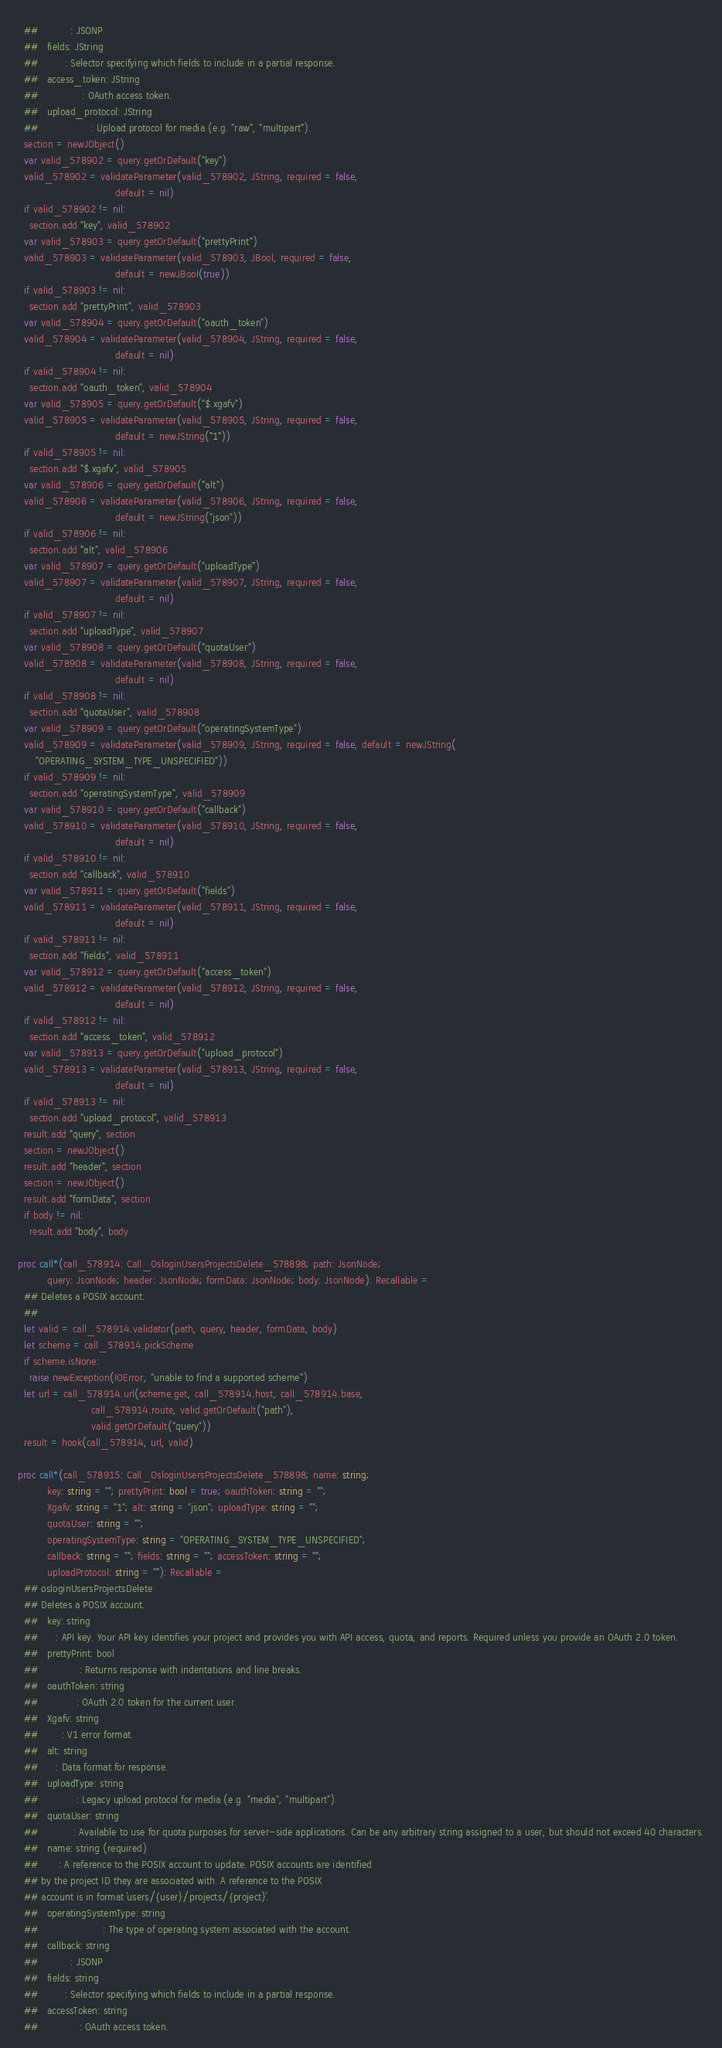<code> <loc_0><loc_0><loc_500><loc_500><_Nim_>  ##           : JSONP
  ##   fields: JString
  ##         : Selector specifying which fields to include in a partial response.
  ##   access_token: JString
  ##               : OAuth access token.
  ##   upload_protocol: JString
  ##                  : Upload protocol for media (e.g. "raw", "multipart").
  section = newJObject()
  var valid_578902 = query.getOrDefault("key")
  valid_578902 = validateParameter(valid_578902, JString, required = false,
                                 default = nil)
  if valid_578902 != nil:
    section.add "key", valid_578902
  var valid_578903 = query.getOrDefault("prettyPrint")
  valid_578903 = validateParameter(valid_578903, JBool, required = false,
                                 default = newJBool(true))
  if valid_578903 != nil:
    section.add "prettyPrint", valid_578903
  var valid_578904 = query.getOrDefault("oauth_token")
  valid_578904 = validateParameter(valid_578904, JString, required = false,
                                 default = nil)
  if valid_578904 != nil:
    section.add "oauth_token", valid_578904
  var valid_578905 = query.getOrDefault("$.xgafv")
  valid_578905 = validateParameter(valid_578905, JString, required = false,
                                 default = newJString("1"))
  if valid_578905 != nil:
    section.add "$.xgafv", valid_578905
  var valid_578906 = query.getOrDefault("alt")
  valid_578906 = validateParameter(valid_578906, JString, required = false,
                                 default = newJString("json"))
  if valid_578906 != nil:
    section.add "alt", valid_578906
  var valid_578907 = query.getOrDefault("uploadType")
  valid_578907 = validateParameter(valid_578907, JString, required = false,
                                 default = nil)
  if valid_578907 != nil:
    section.add "uploadType", valid_578907
  var valid_578908 = query.getOrDefault("quotaUser")
  valid_578908 = validateParameter(valid_578908, JString, required = false,
                                 default = nil)
  if valid_578908 != nil:
    section.add "quotaUser", valid_578908
  var valid_578909 = query.getOrDefault("operatingSystemType")
  valid_578909 = validateParameter(valid_578909, JString, required = false, default = newJString(
      "OPERATING_SYSTEM_TYPE_UNSPECIFIED"))
  if valid_578909 != nil:
    section.add "operatingSystemType", valid_578909
  var valid_578910 = query.getOrDefault("callback")
  valid_578910 = validateParameter(valid_578910, JString, required = false,
                                 default = nil)
  if valid_578910 != nil:
    section.add "callback", valid_578910
  var valid_578911 = query.getOrDefault("fields")
  valid_578911 = validateParameter(valid_578911, JString, required = false,
                                 default = nil)
  if valid_578911 != nil:
    section.add "fields", valid_578911
  var valid_578912 = query.getOrDefault("access_token")
  valid_578912 = validateParameter(valid_578912, JString, required = false,
                                 default = nil)
  if valid_578912 != nil:
    section.add "access_token", valid_578912
  var valid_578913 = query.getOrDefault("upload_protocol")
  valid_578913 = validateParameter(valid_578913, JString, required = false,
                                 default = nil)
  if valid_578913 != nil:
    section.add "upload_protocol", valid_578913
  result.add "query", section
  section = newJObject()
  result.add "header", section
  section = newJObject()
  result.add "formData", section
  if body != nil:
    result.add "body", body

proc call*(call_578914: Call_OsloginUsersProjectsDelete_578898; path: JsonNode;
          query: JsonNode; header: JsonNode; formData: JsonNode; body: JsonNode): Recallable =
  ## Deletes a POSIX account.
  ## 
  let valid = call_578914.validator(path, query, header, formData, body)
  let scheme = call_578914.pickScheme
  if scheme.isNone:
    raise newException(IOError, "unable to find a supported scheme")
  let url = call_578914.url(scheme.get, call_578914.host, call_578914.base,
                         call_578914.route, valid.getOrDefault("path"),
                         valid.getOrDefault("query"))
  result = hook(call_578914, url, valid)

proc call*(call_578915: Call_OsloginUsersProjectsDelete_578898; name: string;
          key: string = ""; prettyPrint: bool = true; oauthToken: string = "";
          Xgafv: string = "1"; alt: string = "json"; uploadType: string = "";
          quotaUser: string = "";
          operatingSystemType: string = "OPERATING_SYSTEM_TYPE_UNSPECIFIED";
          callback: string = ""; fields: string = ""; accessToken: string = "";
          uploadProtocol: string = ""): Recallable =
  ## osloginUsersProjectsDelete
  ## Deletes a POSIX account.
  ##   key: string
  ##      : API key. Your API key identifies your project and provides you with API access, quota, and reports. Required unless you provide an OAuth 2.0 token.
  ##   prettyPrint: bool
  ##              : Returns response with indentations and line breaks.
  ##   oauthToken: string
  ##             : OAuth 2.0 token for the current user.
  ##   Xgafv: string
  ##        : V1 error format.
  ##   alt: string
  ##      : Data format for response.
  ##   uploadType: string
  ##             : Legacy upload protocol for media (e.g. "media", "multipart").
  ##   quotaUser: string
  ##            : Available to use for quota purposes for server-side applications. Can be any arbitrary string assigned to a user, but should not exceed 40 characters.
  ##   name: string (required)
  ##       : A reference to the POSIX account to update. POSIX accounts are identified
  ## by the project ID they are associated with. A reference to the POSIX
  ## account is in format `users/{user}/projects/{project}`.
  ##   operatingSystemType: string
  ##                      : The type of operating system associated with the account.
  ##   callback: string
  ##           : JSONP
  ##   fields: string
  ##         : Selector specifying which fields to include in a partial response.
  ##   accessToken: string
  ##              : OAuth access token.</code> 